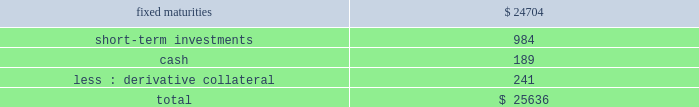Hlikk has four revolving credit facilities in support of operations .
Two of the credit facilities have no amounts drawn as of december 31 , 2013 with borrowing limits of approximately a55 billion , or $ 48 each , and individually have expiration dates of january 5 , 2015 and september 30 , 2014 .
In december 2013 , hlikk entered into two new revolving credit facility agreements with two japanese banks in order to finance certain withholding taxes on mutual fund gains , that are subsequently credited when hlikk files its 2019 income tax returns .
At december 31 , 2013 , hlikk had drawn the total borrowing limits of a55 billion , or $ 48 , and a520 billion , or $ 190 on these credit facilities .
The a55 billion credit facility accrues interest at a variable rate based on the one month tokyo interbank offering rate ( tibor ) plus 3 bps , which as of december 31 , 2013 the interest rate was 15 bps , and the a520 billion credit facility accrues interest at a variable rate based on tibor plus 3 bps , or the actual cost of funding , which as of december 31 , 2013 the interest rate was 20 bps .
Both of the credit facilities expire on september 30 , 2014 .
Derivative commitments certain of the company 2019s derivative agreements contain provisions that are tied to the financial strength ratings of the individual legal entity that entered into the derivative agreement as set by nationally recognized statistical rating agencies .
If the legal entity 2019s financial strength were to fall below certain ratings , the counterparties to the derivative agreements could demand immediate and ongoing full collateralization and in certain instances demand immediate settlement of all outstanding derivative positions traded under each impacted bilateral agreement .
The settlement amount is determined by netting the derivative positions transacted under each agreement .
If the termination rights were to be exercised by the counterparties , it could impact the legal entity 2019s ability to conduct hedging activities by increasing the associated costs and decreasing the willingness of counterparties to transact with the legal entity .
The aggregate fair value of all derivative instruments with credit-risk-related contingent features that are in a net liability position as of december 31 , 2013 was $ 1.2 billion .
Of this $ 1.2 billion the legal entities have posted collateral of $ 1.4 billion in the normal course of business .
In addition , the company has posted collateral of $ 44 associated with a customized gmwb derivative .
Based on derivative market values as of december 31 , 2013 , a downgrade of one level below the current financial strength ratings by either moody 2019s or s&p could require approximately an additional $ 12 to be posted as collateral .
Based on derivative market values as of december 31 , 2013 , a downgrade by either moody 2019s or s&p of two levels below the legal entities 2019 current financial strength ratings could require approximately an additional $ 33 of assets to be posted as collateral .
These collateral amounts could change as derivative market values change , as a result of changes in our hedging activities or to the extent changes in contractual terms are negotiated .
The nature of the collateral that we would post , if required , would be primarily in the form of u.s .
Treasury bills , u.s .
Treasury notes and government agency securities .
As of december 31 , 2013 , the aggregate notional amount and fair value of derivative relationships that could be subject to immediate termination in the event of rating agency downgrades to either bbb+ or baa1 was $ 536 and $ ( 17 ) , respectively .
Insurance operations current and expected patterns of claim frequency and severity or surrenders may change from period to period but continue to be within historical norms and , therefore , the company 2019s insurance operations 2019 current liquidity position is considered to be sufficient to meet anticipated demands over the next twelve months , including any obligations related to the company 2019s restructuring activities .
For a discussion and tabular presentation of the company 2019s current contractual obligations by period , refer to off-balance sheet arrangements and aggregate contractual obligations within the capital resources and liquidity section of the md&a .
The principal sources of operating funds are premiums , fees earned from assets under management and investment income , while investing cash flows originate from maturities and sales of invested assets .
The primary uses of funds are to pay claims , claim adjustment expenses , commissions and other underwriting expenses , to purchase new investments and to make dividend payments to the hfsg holding company .
The company 2019s insurance operations consist of property and casualty insurance products ( collectively referred to as 201cproperty & casualty operations 201d ) and life insurance and legacy annuity products ( collectively referred to as 201clife operations 201d ) .
Property & casualty operations property & casualty operations holds fixed maturity securities including a significant short-term investment position ( securities with maturities of one year or less at the time of purchase ) to meet liquidity needs .
As of december 31 , 2013 , property & casualty operations 2019 fixed maturities , short-term investments , and cash are summarized as follows: .

What percent of total amount is held on fixed maturities? 
Computations: (24704 / 25636)
Answer: 0.96364. 